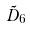Convert formula to latex. <formula><loc_0><loc_0><loc_500><loc_500>\tilde { D } _ { 6 }</formula> 